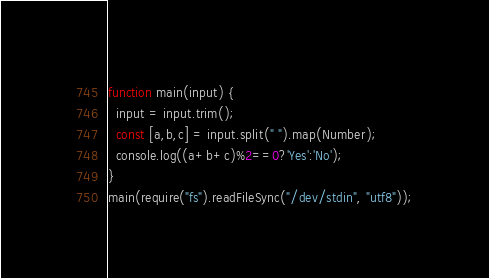Convert code to text. <code><loc_0><loc_0><loc_500><loc_500><_JavaScript_>function main(input) {
  input = input.trim();
  const [a,b,c] = input.split(" ").map(Number);
  console.log((a+b+c)%2==0?'Yes':'No');
}
main(require("fs").readFileSync("/dev/stdin", "utf8"));</code> 